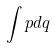Convert formula to latex. <formula><loc_0><loc_0><loc_500><loc_500>\int p d q</formula> 